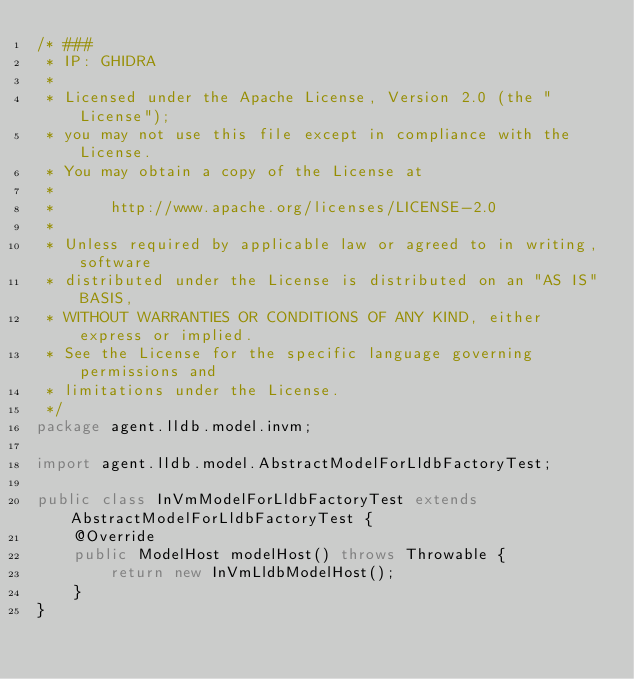<code> <loc_0><loc_0><loc_500><loc_500><_Java_>/* ###
 * IP: GHIDRA
 *
 * Licensed under the Apache License, Version 2.0 (the "License");
 * you may not use this file except in compliance with the License.
 * You may obtain a copy of the License at
 * 
 *      http://www.apache.org/licenses/LICENSE-2.0
 * 
 * Unless required by applicable law or agreed to in writing, software
 * distributed under the License is distributed on an "AS IS" BASIS,
 * WITHOUT WARRANTIES OR CONDITIONS OF ANY KIND, either express or implied.
 * See the License for the specific language governing permissions and
 * limitations under the License.
 */
package agent.lldb.model.invm;

import agent.lldb.model.AbstractModelForLldbFactoryTest;

public class InVmModelForLldbFactoryTest extends AbstractModelForLldbFactoryTest {
	@Override
	public ModelHost modelHost() throws Throwable {
		return new InVmLldbModelHost();
	}
}
</code> 